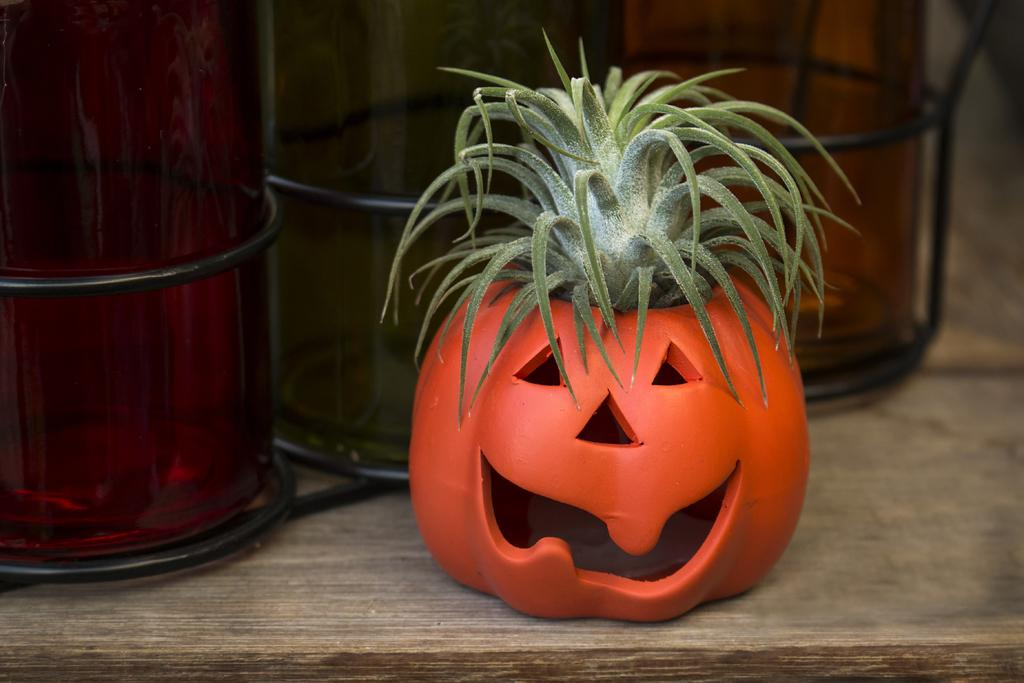What is the main object in the image? There is a pumpkin in the image. What is growing on the pumpkin? There is a plant on the pumpkin. How many containers are visible in the image? There are 2 containers in the image. What is the surface that the pumpkin, plant, and containers are resting on? They are all on a wooden plank. What type of needle is being used to sew the pumpkin in the image? There is no needle or sewing activity present in the image. Can you see any insects crawling on the pumpkin in the image? There are no insects visible on the pumpkin in the image. 